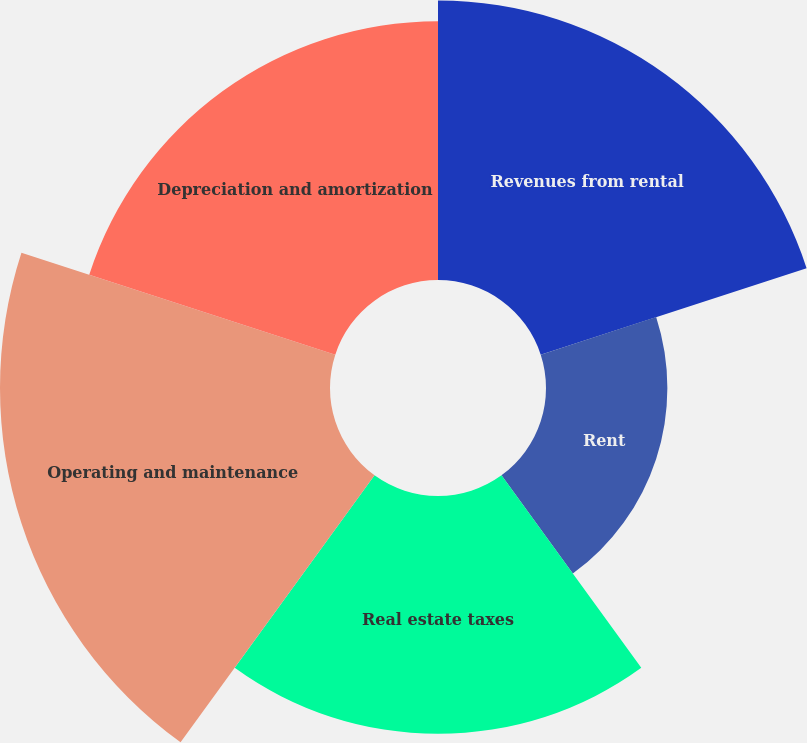<chart> <loc_0><loc_0><loc_500><loc_500><pie_chart><fcel>Revenues from rental<fcel>Rent<fcel>Real estate taxes<fcel>Operating and maintenance<fcel>Depreciation and amortization<nl><fcel>22.78%<fcel>9.89%<fcel>19.38%<fcel>26.89%<fcel>21.08%<nl></chart> 